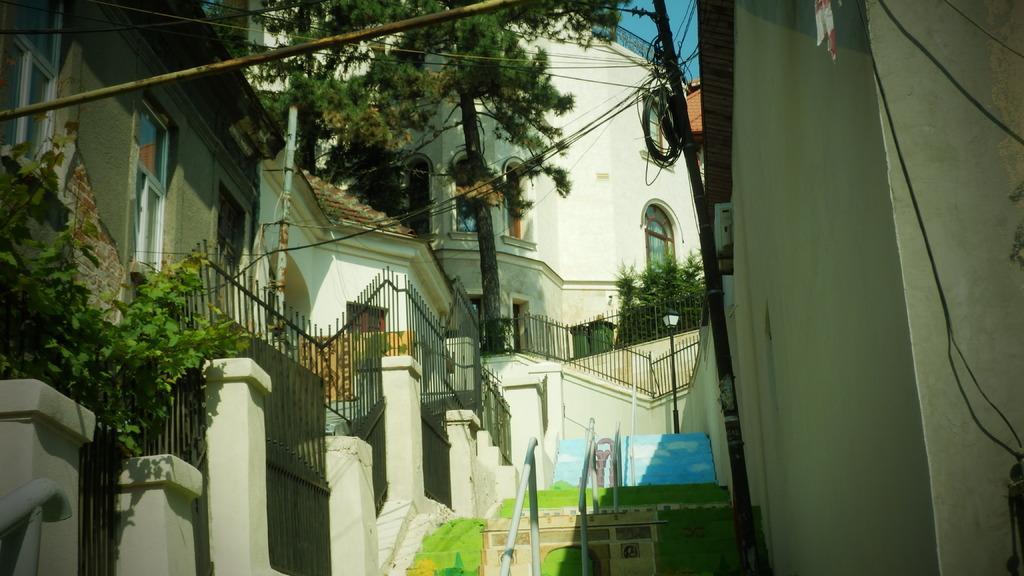Describe this image in one or two sentences. On the left side of the image we can see building and compound wall of iron roads. In the middle of the image we can building, steps and tree. On the right side of the image we can see wall, current pole and wires. 